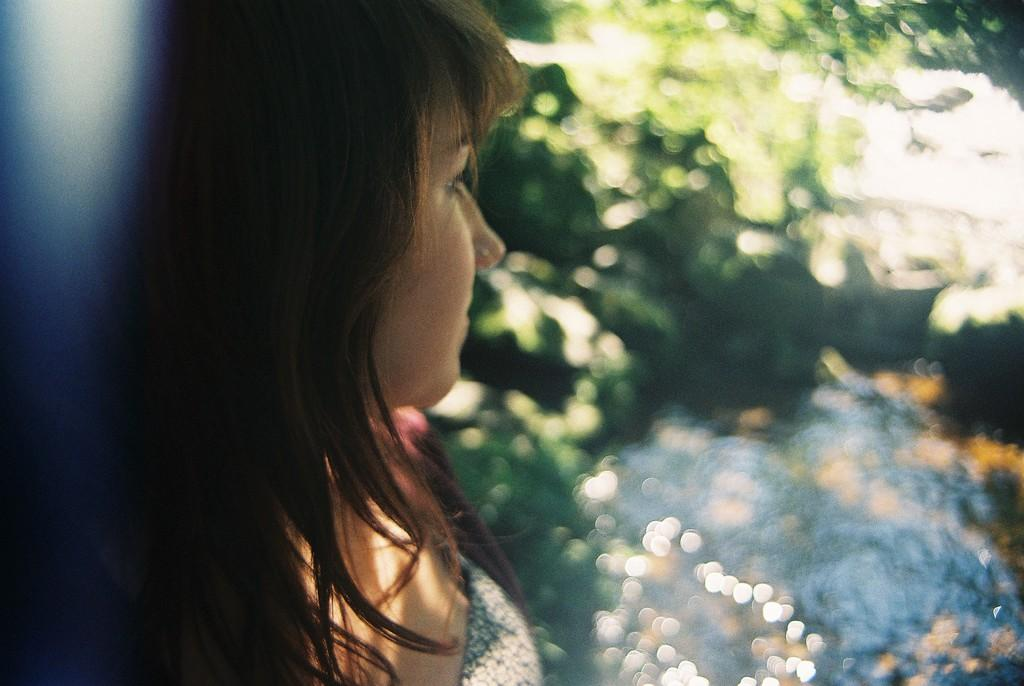Who is the main subject in the image? There is a woman in the image. Can you describe the background of the image? The background of the image is blurry. What type of structure is the beggar leaning on in the image? There is no beggar or structure present in the image; it only features a woman with a blurry background. 